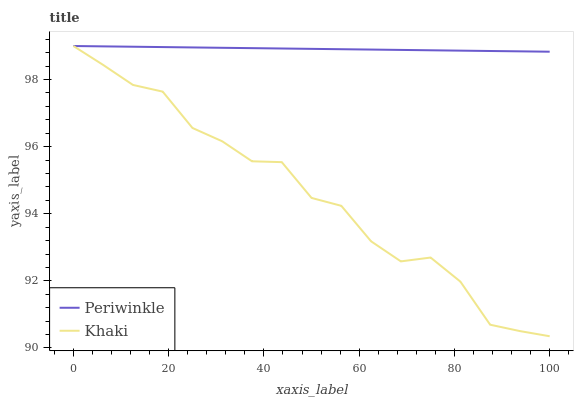Does Khaki have the minimum area under the curve?
Answer yes or no. Yes. Does Periwinkle have the maximum area under the curve?
Answer yes or no. Yes. Does Periwinkle have the minimum area under the curve?
Answer yes or no. No. Is Periwinkle the smoothest?
Answer yes or no. Yes. Is Khaki the roughest?
Answer yes or no. Yes. Is Periwinkle the roughest?
Answer yes or no. No. Does Khaki have the lowest value?
Answer yes or no. Yes. Does Periwinkle have the lowest value?
Answer yes or no. No. Does Periwinkle have the highest value?
Answer yes or no. Yes. Does Khaki intersect Periwinkle?
Answer yes or no. Yes. Is Khaki less than Periwinkle?
Answer yes or no. No. Is Khaki greater than Periwinkle?
Answer yes or no. No. 